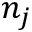<formula> <loc_0><loc_0><loc_500><loc_500>n _ { j }</formula> 